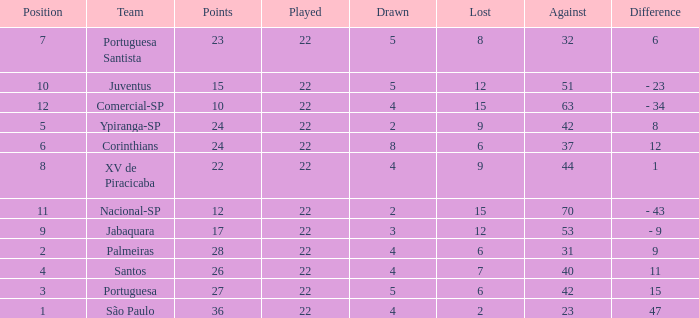Which Played has a Lost larger than 9, and a Points smaller than 15, and a Position smaller than 12, and a Drawn smaller than 2? None. 